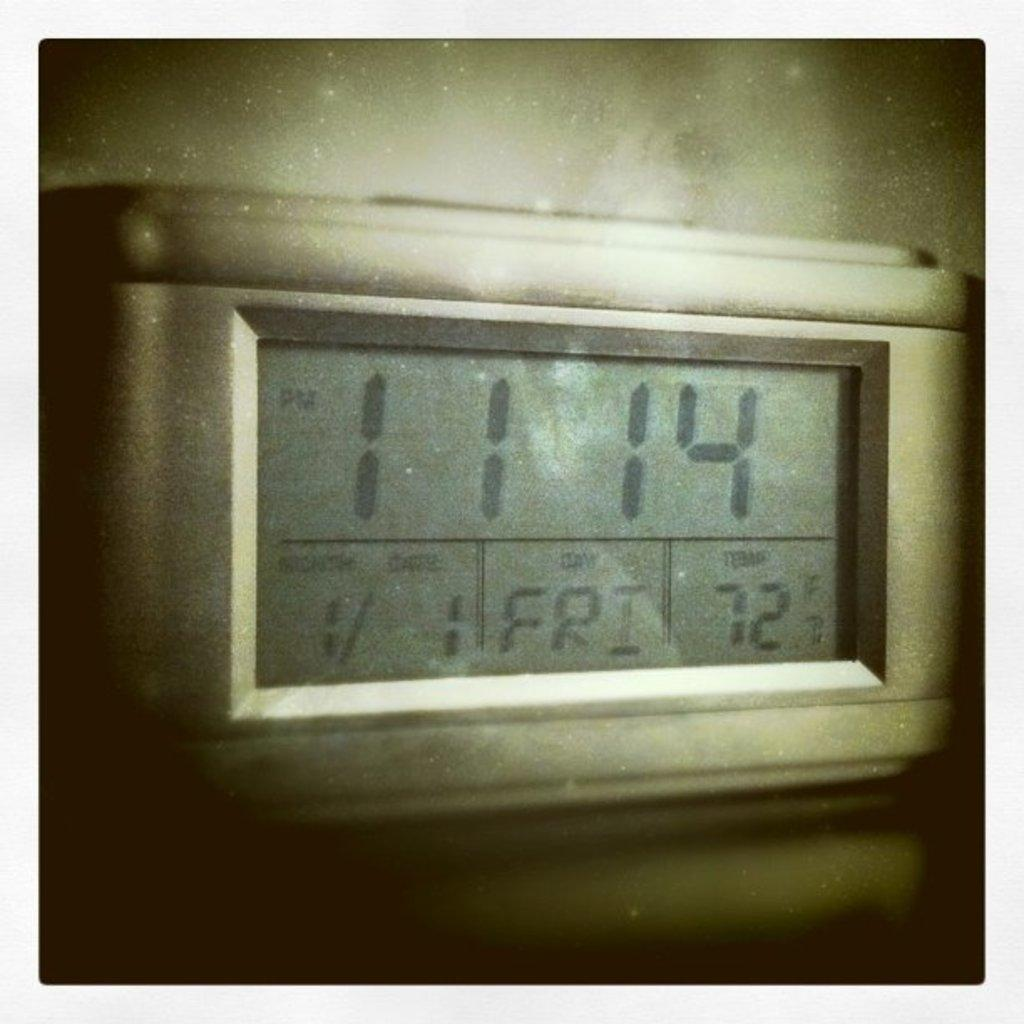Provide a one-sentence caption for the provided image. A thermostat display that reads 11:14 pm, on 1/1 Friday 72 degrees F. 